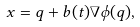<formula> <loc_0><loc_0><loc_500><loc_500>x = q + b ( t ) \nabla \phi ( q ) ,</formula> 